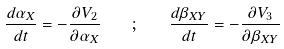<formula> <loc_0><loc_0><loc_500><loc_500>\frac { d \alpha _ { X } } { d t } = - \frac { \partial V _ { 2 } } { \partial \alpha _ { X } } \quad ; \quad \frac { d \beta _ { X Y } } { d t } = - \frac { \partial V _ { 3 } } { \partial \beta _ { X Y } }</formula> 